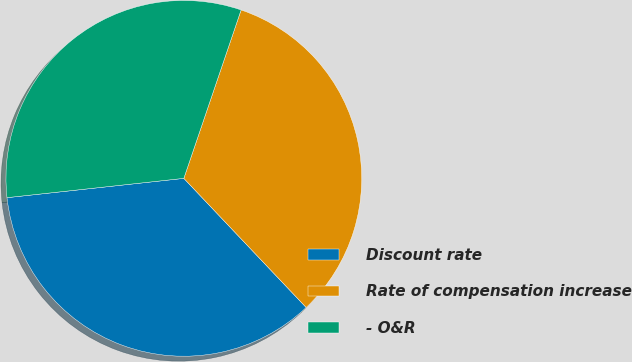<chart> <loc_0><loc_0><loc_500><loc_500><pie_chart><fcel>Discount rate<fcel>Rate of compensation increase<fcel>- O&R<nl><fcel>35.34%<fcel>32.71%<fcel>31.95%<nl></chart> 